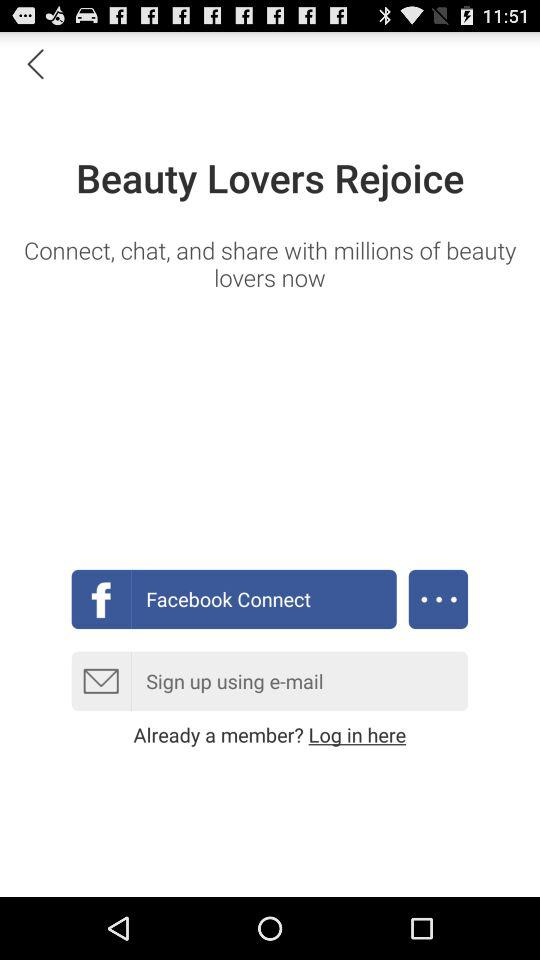What is user name?
When the provided information is insufficient, respond with <no answer>. <no answer> 